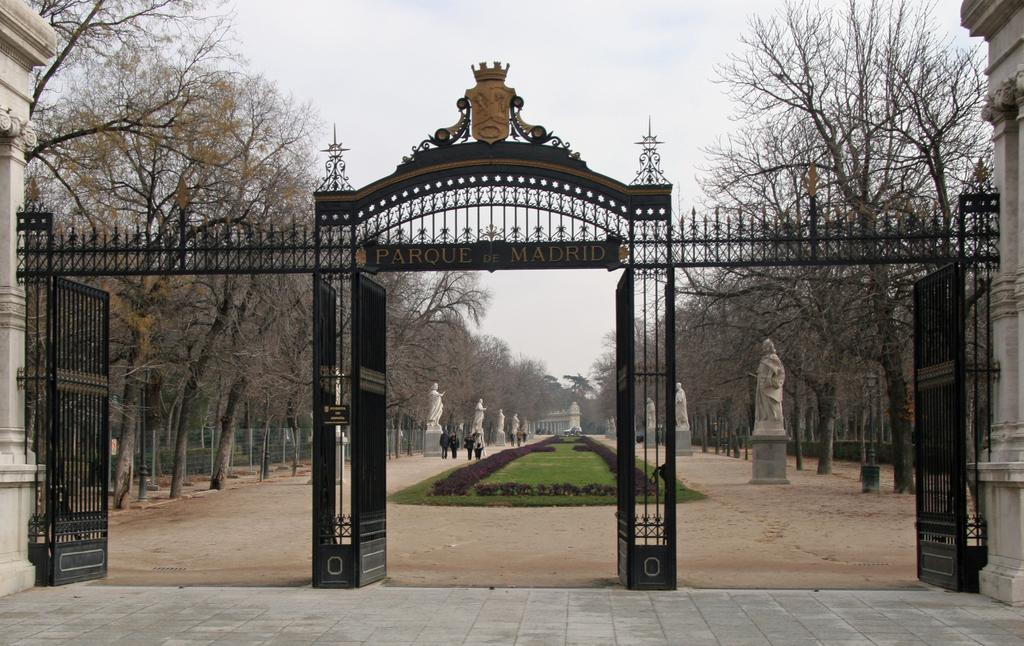What structure can be seen in the image? There is a gate in the image. What type of objects are present near the gate? There are white color statues in the image. What type of vegetation is visible in the image? There are trees in the image. What are the people in the image doing? There are people walking in the image. What is the color of the sky in the image? The sky appears to be white in color. What type of comfort can be seen in the image? There is no specific comfort item or feature present in the image. What type of lip can be seen on the statues in the image? The statues in the image do not have lips, as they are not human figures. 